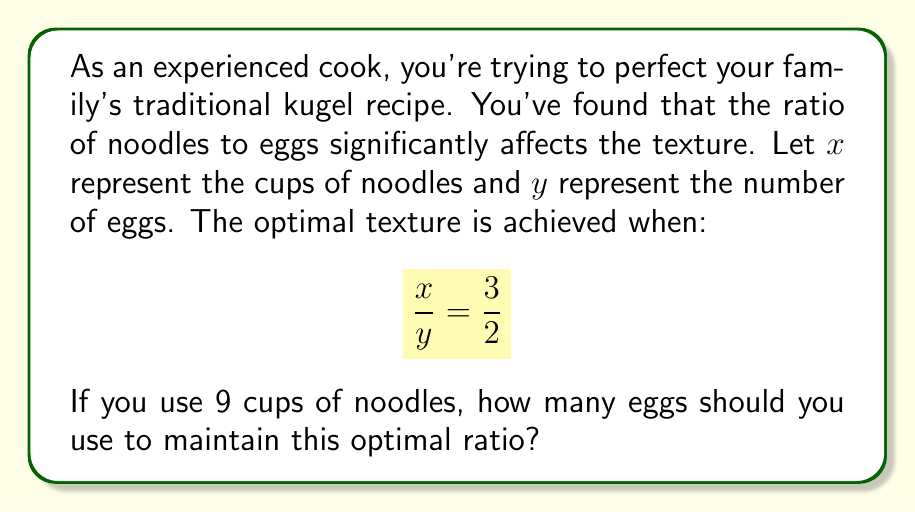Could you help me with this problem? Let's approach this step-by-step:

1) We're given the optimal ratio: $\frac{x}{y} = \frac{3}{2}$

2) We know that $x = 9$ cups of noodles

3) We can set up an equation:
   
   $$\frac{9}{y} = \frac{3}{2}$$

4) To solve for $y$, we can cross-multiply:
   
   $$9 \cdot 2 = y \cdot 3$$
   
   $$18 = 3y$$

5) Divide both sides by 3:
   
   $$\frac{18}{3} = y$$
   
   $$6 = y$$

Therefore, to maintain the optimal ratio with 9 cups of noodles, you should use 6 eggs.
Answer: 6 eggs 